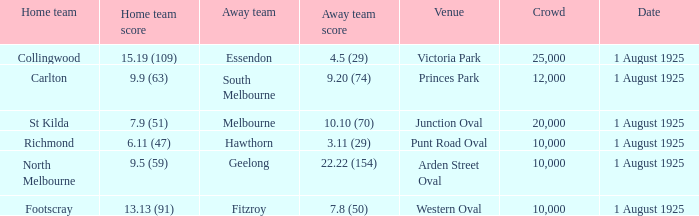At the match where the away team scored 4.5 (29), what was the crowd size? 1.0. 